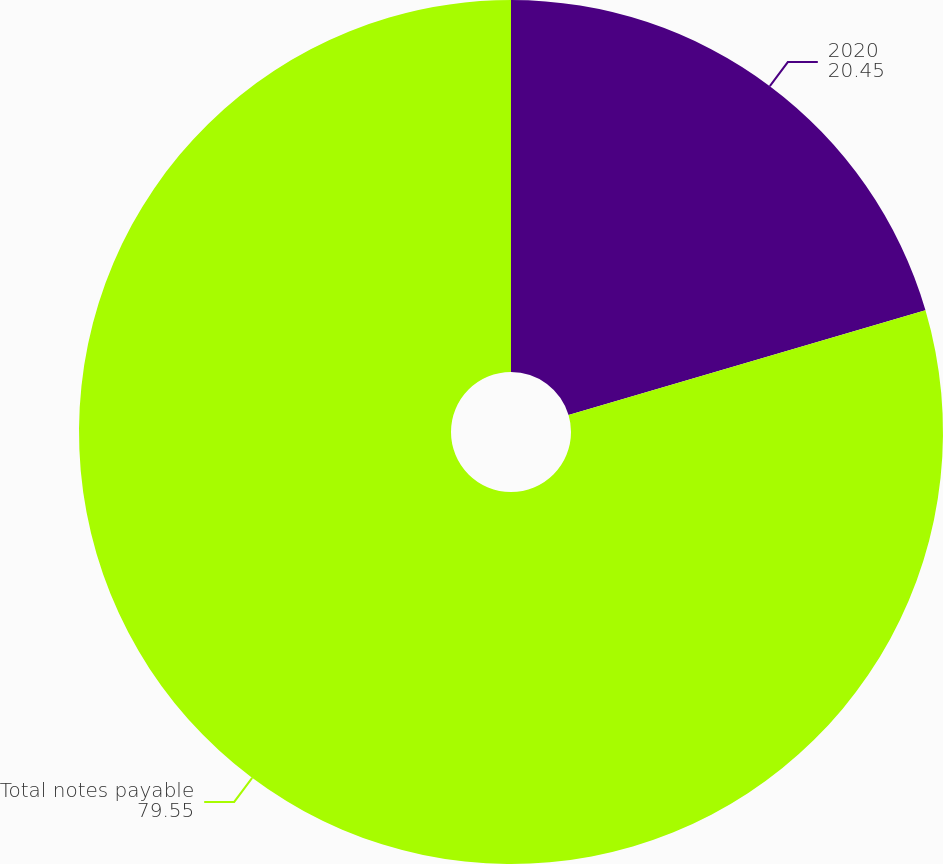Convert chart. <chart><loc_0><loc_0><loc_500><loc_500><pie_chart><fcel>2020<fcel>Total notes payable<nl><fcel>20.45%<fcel>79.55%<nl></chart> 